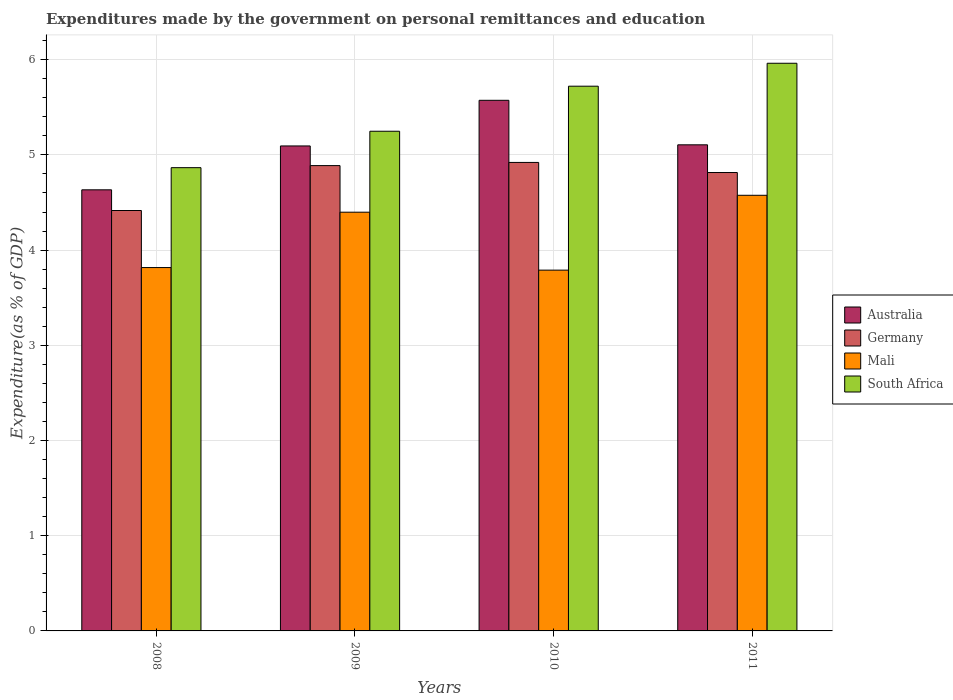How many different coloured bars are there?
Keep it short and to the point. 4. Are the number of bars per tick equal to the number of legend labels?
Keep it short and to the point. Yes. Are the number of bars on each tick of the X-axis equal?
Provide a succinct answer. Yes. In how many cases, is the number of bars for a given year not equal to the number of legend labels?
Keep it short and to the point. 0. What is the expenditures made by the government on personal remittances and education in Australia in 2011?
Your answer should be very brief. 5.11. Across all years, what is the maximum expenditures made by the government on personal remittances and education in South Africa?
Provide a short and direct response. 5.96. Across all years, what is the minimum expenditures made by the government on personal remittances and education in Germany?
Offer a terse response. 4.42. In which year was the expenditures made by the government on personal remittances and education in Mali minimum?
Make the answer very short. 2010. What is the total expenditures made by the government on personal remittances and education in Mali in the graph?
Offer a terse response. 16.58. What is the difference between the expenditures made by the government on personal remittances and education in Australia in 2008 and that in 2009?
Keep it short and to the point. -0.46. What is the difference between the expenditures made by the government on personal remittances and education in Australia in 2008 and the expenditures made by the government on personal remittances and education in Mali in 2009?
Make the answer very short. 0.24. What is the average expenditures made by the government on personal remittances and education in Germany per year?
Make the answer very short. 4.76. In the year 2008, what is the difference between the expenditures made by the government on personal remittances and education in South Africa and expenditures made by the government on personal remittances and education in Germany?
Offer a very short reply. 0.45. In how many years, is the expenditures made by the government on personal remittances and education in Germany greater than 2.2 %?
Ensure brevity in your answer.  4. What is the ratio of the expenditures made by the government on personal remittances and education in Germany in 2008 to that in 2010?
Make the answer very short. 0.9. What is the difference between the highest and the second highest expenditures made by the government on personal remittances and education in South Africa?
Give a very brief answer. 0.24. What is the difference between the highest and the lowest expenditures made by the government on personal remittances and education in Mali?
Ensure brevity in your answer.  0.79. Is it the case that in every year, the sum of the expenditures made by the government on personal remittances and education in Germany and expenditures made by the government on personal remittances and education in Australia is greater than the sum of expenditures made by the government on personal remittances and education in Mali and expenditures made by the government on personal remittances and education in South Africa?
Make the answer very short. No. What does the 1st bar from the left in 2008 represents?
Offer a terse response. Australia. What does the 2nd bar from the right in 2008 represents?
Ensure brevity in your answer.  Mali. Is it the case that in every year, the sum of the expenditures made by the government on personal remittances and education in Australia and expenditures made by the government on personal remittances and education in South Africa is greater than the expenditures made by the government on personal remittances and education in Mali?
Provide a succinct answer. Yes. Are all the bars in the graph horizontal?
Ensure brevity in your answer.  No. How many years are there in the graph?
Your response must be concise. 4. Does the graph contain grids?
Keep it short and to the point. Yes. Where does the legend appear in the graph?
Offer a terse response. Center right. How are the legend labels stacked?
Keep it short and to the point. Vertical. What is the title of the graph?
Offer a very short reply. Expenditures made by the government on personal remittances and education. Does "Europe(all income levels)" appear as one of the legend labels in the graph?
Ensure brevity in your answer.  No. What is the label or title of the X-axis?
Keep it short and to the point. Years. What is the label or title of the Y-axis?
Your answer should be very brief. Expenditure(as % of GDP). What is the Expenditure(as % of GDP) of Australia in 2008?
Make the answer very short. 4.63. What is the Expenditure(as % of GDP) of Germany in 2008?
Provide a short and direct response. 4.42. What is the Expenditure(as % of GDP) in Mali in 2008?
Make the answer very short. 3.82. What is the Expenditure(as % of GDP) in South Africa in 2008?
Give a very brief answer. 4.87. What is the Expenditure(as % of GDP) of Australia in 2009?
Offer a terse response. 5.09. What is the Expenditure(as % of GDP) of Germany in 2009?
Provide a short and direct response. 4.89. What is the Expenditure(as % of GDP) in Mali in 2009?
Offer a very short reply. 4.4. What is the Expenditure(as % of GDP) of South Africa in 2009?
Offer a terse response. 5.25. What is the Expenditure(as % of GDP) in Australia in 2010?
Offer a very short reply. 5.57. What is the Expenditure(as % of GDP) of Germany in 2010?
Make the answer very short. 4.92. What is the Expenditure(as % of GDP) of Mali in 2010?
Your answer should be compact. 3.79. What is the Expenditure(as % of GDP) in South Africa in 2010?
Offer a terse response. 5.72. What is the Expenditure(as % of GDP) of Australia in 2011?
Give a very brief answer. 5.11. What is the Expenditure(as % of GDP) of Germany in 2011?
Give a very brief answer. 4.81. What is the Expenditure(as % of GDP) of Mali in 2011?
Your answer should be very brief. 4.58. What is the Expenditure(as % of GDP) in South Africa in 2011?
Make the answer very short. 5.96. Across all years, what is the maximum Expenditure(as % of GDP) of Australia?
Give a very brief answer. 5.57. Across all years, what is the maximum Expenditure(as % of GDP) in Germany?
Offer a very short reply. 4.92. Across all years, what is the maximum Expenditure(as % of GDP) in Mali?
Provide a succinct answer. 4.58. Across all years, what is the maximum Expenditure(as % of GDP) of South Africa?
Give a very brief answer. 5.96. Across all years, what is the minimum Expenditure(as % of GDP) of Australia?
Make the answer very short. 4.63. Across all years, what is the minimum Expenditure(as % of GDP) in Germany?
Offer a very short reply. 4.42. Across all years, what is the minimum Expenditure(as % of GDP) of Mali?
Your response must be concise. 3.79. Across all years, what is the minimum Expenditure(as % of GDP) of South Africa?
Your answer should be compact. 4.87. What is the total Expenditure(as % of GDP) of Australia in the graph?
Ensure brevity in your answer.  20.41. What is the total Expenditure(as % of GDP) in Germany in the graph?
Offer a very short reply. 19.04. What is the total Expenditure(as % of GDP) of Mali in the graph?
Keep it short and to the point. 16.58. What is the total Expenditure(as % of GDP) in South Africa in the graph?
Your answer should be very brief. 21.8. What is the difference between the Expenditure(as % of GDP) of Australia in 2008 and that in 2009?
Give a very brief answer. -0.46. What is the difference between the Expenditure(as % of GDP) in Germany in 2008 and that in 2009?
Ensure brevity in your answer.  -0.47. What is the difference between the Expenditure(as % of GDP) in Mali in 2008 and that in 2009?
Your answer should be very brief. -0.58. What is the difference between the Expenditure(as % of GDP) in South Africa in 2008 and that in 2009?
Make the answer very short. -0.38. What is the difference between the Expenditure(as % of GDP) of Australia in 2008 and that in 2010?
Provide a succinct answer. -0.94. What is the difference between the Expenditure(as % of GDP) of Germany in 2008 and that in 2010?
Provide a short and direct response. -0.51. What is the difference between the Expenditure(as % of GDP) of Mali in 2008 and that in 2010?
Your answer should be very brief. 0.03. What is the difference between the Expenditure(as % of GDP) in South Africa in 2008 and that in 2010?
Give a very brief answer. -0.86. What is the difference between the Expenditure(as % of GDP) of Australia in 2008 and that in 2011?
Make the answer very short. -0.47. What is the difference between the Expenditure(as % of GDP) of Germany in 2008 and that in 2011?
Your answer should be very brief. -0.4. What is the difference between the Expenditure(as % of GDP) of Mali in 2008 and that in 2011?
Your answer should be very brief. -0.76. What is the difference between the Expenditure(as % of GDP) in South Africa in 2008 and that in 2011?
Provide a succinct answer. -1.1. What is the difference between the Expenditure(as % of GDP) in Australia in 2009 and that in 2010?
Make the answer very short. -0.48. What is the difference between the Expenditure(as % of GDP) in Germany in 2009 and that in 2010?
Keep it short and to the point. -0.03. What is the difference between the Expenditure(as % of GDP) in Mali in 2009 and that in 2010?
Your answer should be very brief. 0.61. What is the difference between the Expenditure(as % of GDP) of South Africa in 2009 and that in 2010?
Your answer should be very brief. -0.47. What is the difference between the Expenditure(as % of GDP) in Australia in 2009 and that in 2011?
Provide a short and direct response. -0.01. What is the difference between the Expenditure(as % of GDP) in Germany in 2009 and that in 2011?
Keep it short and to the point. 0.07. What is the difference between the Expenditure(as % of GDP) in Mali in 2009 and that in 2011?
Keep it short and to the point. -0.18. What is the difference between the Expenditure(as % of GDP) of South Africa in 2009 and that in 2011?
Offer a terse response. -0.71. What is the difference between the Expenditure(as % of GDP) of Australia in 2010 and that in 2011?
Ensure brevity in your answer.  0.47. What is the difference between the Expenditure(as % of GDP) of Germany in 2010 and that in 2011?
Provide a short and direct response. 0.11. What is the difference between the Expenditure(as % of GDP) in Mali in 2010 and that in 2011?
Your response must be concise. -0.79. What is the difference between the Expenditure(as % of GDP) in South Africa in 2010 and that in 2011?
Your response must be concise. -0.24. What is the difference between the Expenditure(as % of GDP) of Australia in 2008 and the Expenditure(as % of GDP) of Germany in 2009?
Make the answer very short. -0.25. What is the difference between the Expenditure(as % of GDP) in Australia in 2008 and the Expenditure(as % of GDP) in Mali in 2009?
Your answer should be compact. 0.23. What is the difference between the Expenditure(as % of GDP) in Australia in 2008 and the Expenditure(as % of GDP) in South Africa in 2009?
Keep it short and to the point. -0.62. What is the difference between the Expenditure(as % of GDP) of Germany in 2008 and the Expenditure(as % of GDP) of Mali in 2009?
Offer a very short reply. 0.02. What is the difference between the Expenditure(as % of GDP) in Germany in 2008 and the Expenditure(as % of GDP) in South Africa in 2009?
Provide a short and direct response. -0.83. What is the difference between the Expenditure(as % of GDP) in Mali in 2008 and the Expenditure(as % of GDP) in South Africa in 2009?
Your answer should be very brief. -1.43. What is the difference between the Expenditure(as % of GDP) in Australia in 2008 and the Expenditure(as % of GDP) in Germany in 2010?
Your answer should be compact. -0.29. What is the difference between the Expenditure(as % of GDP) in Australia in 2008 and the Expenditure(as % of GDP) in Mali in 2010?
Keep it short and to the point. 0.84. What is the difference between the Expenditure(as % of GDP) in Australia in 2008 and the Expenditure(as % of GDP) in South Africa in 2010?
Ensure brevity in your answer.  -1.09. What is the difference between the Expenditure(as % of GDP) in Germany in 2008 and the Expenditure(as % of GDP) in Mali in 2010?
Offer a terse response. 0.63. What is the difference between the Expenditure(as % of GDP) of Germany in 2008 and the Expenditure(as % of GDP) of South Africa in 2010?
Offer a very short reply. -1.31. What is the difference between the Expenditure(as % of GDP) of Mali in 2008 and the Expenditure(as % of GDP) of South Africa in 2010?
Ensure brevity in your answer.  -1.9. What is the difference between the Expenditure(as % of GDP) in Australia in 2008 and the Expenditure(as % of GDP) in Germany in 2011?
Provide a short and direct response. -0.18. What is the difference between the Expenditure(as % of GDP) in Australia in 2008 and the Expenditure(as % of GDP) in Mali in 2011?
Provide a short and direct response. 0.06. What is the difference between the Expenditure(as % of GDP) of Australia in 2008 and the Expenditure(as % of GDP) of South Africa in 2011?
Your response must be concise. -1.33. What is the difference between the Expenditure(as % of GDP) of Germany in 2008 and the Expenditure(as % of GDP) of Mali in 2011?
Provide a succinct answer. -0.16. What is the difference between the Expenditure(as % of GDP) in Germany in 2008 and the Expenditure(as % of GDP) in South Africa in 2011?
Your answer should be very brief. -1.55. What is the difference between the Expenditure(as % of GDP) of Mali in 2008 and the Expenditure(as % of GDP) of South Africa in 2011?
Keep it short and to the point. -2.15. What is the difference between the Expenditure(as % of GDP) of Australia in 2009 and the Expenditure(as % of GDP) of Germany in 2010?
Offer a very short reply. 0.17. What is the difference between the Expenditure(as % of GDP) in Australia in 2009 and the Expenditure(as % of GDP) in Mali in 2010?
Offer a terse response. 1.3. What is the difference between the Expenditure(as % of GDP) in Australia in 2009 and the Expenditure(as % of GDP) in South Africa in 2010?
Ensure brevity in your answer.  -0.63. What is the difference between the Expenditure(as % of GDP) in Germany in 2009 and the Expenditure(as % of GDP) in Mali in 2010?
Make the answer very short. 1.1. What is the difference between the Expenditure(as % of GDP) in Germany in 2009 and the Expenditure(as % of GDP) in South Africa in 2010?
Your answer should be very brief. -0.83. What is the difference between the Expenditure(as % of GDP) in Mali in 2009 and the Expenditure(as % of GDP) in South Africa in 2010?
Offer a terse response. -1.32. What is the difference between the Expenditure(as % of GDP) of Australia in 2009 and the Expenditure(as % of GDP) of Germany in 2011?
Give a very brief answer. 0.28. What is the difference between the Expenditure(as % of GDP) of Australia in 2009 and the Expenditure(as % of GDP) of Mali in 2011?
Offer a very short reply. 0.52. What is the difference between the Expenditure(as % of GDP) in Australia in 2009 and the Expenditure(as % of GDP) in South Africa in 2011?
Make the answer very short. -0.87. What is the difference between the Expenditure(as % of GDP) in Germany in 2009 and the Expenditure(as % of GDP) in Mali in 2011?
Your answer should be compact. 0.31. What is the difference between the Expenditure(as % of GDP) in Germany in 2009 and the Expenditure(as % of GDP) in South Africa in 2011?
Provide a short and direct response. -1.08. What is the difference between the Expenditure(as % of GDP) of Mali in 2009 and the Expenditure(as % of GDP) of South Africa in 2011?
Make the answer very short. -1.56. What is the difference between the Expenditure(as % of GDP) in Australia in 2010 and the Expenditure(as % of GDP) in Germany in 2011?
Provide a short and direct response. 0.76. What is the difference between the Expenditure(as % of GDP) in Australia in 2010 and the Expenditure(as % of GDP) in Mali in 2011?
Your answer should be compact. 1. What is the difference between the Expenditure(as % of GDP) in Australia in 2010 and the Expenditure(as % of GDP) in South Africa in 2011?
Offer a terse response. -0.39. What is the difference between the Expenditure(as % of GDP) of Germany in 2010 and the Expenditure(as % of GDP) of Mali in 2011?
Ensure brevity in your answer.  0.34. What is the difference between the Expenditure(as % of GDP) in Germany in 2010 and the Expenditure(as % of GDP) in South Africa in 2011?
Provide a succinct answer. -1.04. What is the difference between the Expenditure(as % of GDP) in Mali in 2010 and the Expenditure(as % of GDP) in South Africa in 2011?
Keep it short and to the point. -2.17. What is the average Expenditure(as % of GDP) of Australia per year?
Your answer should be compact. 5.1. What is the average Expenditure(as % of GDP) in Germany per year?
Keep it short and to the point. 4.76. What is the average Expenditure(as % of GDP) of Mali per year?
Make the answer very short. 4.15. What is the average Expenditure(as % of GDP) in South Africa per year?
Give a very brief answer. 5.45. In the year 2008, what is the difference between the Expenditure(as % of GDP) of Australia and Expenditure(as % of GDP) of Germany?
Offer a very short reply. 0.22. In the year 2008, what is the difference between the Expenditure(as % of GDP) of Australia and Expenditure(as % of GDP) of Mali?
Your answer should be compact. 0.82. In the year 2008, what is the difference between the Expenditure(as % of GDP) of Australia and Expenditure(as % of GDP) of South Africa?
Your answer should be compact. -0.23. In the year 2008, what is the difference between the Expenditure(as % of GDP) in Germany and Expenditure(as % of GDP) in Mali?
Make the answer very short. 0.6. In the year 2008, what is the difference between the Expenditure(as % of GDP) of Germany and Expenditure(as % of GDP) of South Africa?
Keep it short and to the point. -0.45. In the year 2008, what is the difference between the Expenditure(as % of GDP) of Mali and Expenditure(as % of GDP) of South Africa?
Provide a short and direct response. -1.05. In the year 2009, what is the difference between the Expenditure(as % of GDP) of Australia and Expenditure(as % of GDP) of Germany?
Your answer should be compact. 0.21. In the year 2009, what is the difference between the Expenditure(as % of GDP) in Australia and Expenditure(as % of GDP) in Mali?
Make the answer very short. 0.7. In the year 2009, what is the difference between the Expenditure(as % of GDP) of Australia and Expenditure(as % of GDP) of South Africa?
Offer a terse response. -0.15. In the year 2009, what is the difference between the Expenditure(as % of GDP) of Germany and Expenditure(as % of GDP) of Mali?
Offer a very short reply. 0.49. In the year 2009, what is the difference between the Expenditure(as % of GDP) of Germany and Expenditure(as % of GDP) of South Africa?
Your response must be concise. -0.36. In the year 2009, what is the difference between the Expenditure(as % of GDP) in Mali and Expenditure(as % of GDP) in South Africa?
Offer a very short reply. -0.85. In the year 2010, what is the difference between the Expenditure(as % of GDP) of Australia and Expenditure(as % of GDP) of Germany?
Your response must be concise. 0.65. In the year 2010, what is the difference between the Expenditure(as % of GDP) in Australia and Expenditure(as % of GDP) in Mali?
Your answer should be very brief. 1.78. In the year 2010, what is the difference between the Expenditure(as % of GDP) in Australia and Expenditure(as % of GDP) in South Africa?
Give a very brief answer. -0.15. In the year 2010, what is the difference between the Expenditure(as % of GDP) of Germany and Expenditure(as % of GDP) of Mali?
Provide a short and direct response. 1.13. In the year 2010, what is the difference between the Expenditure(as % of GDP) of Germany and Expenditure(as % of GDP) of South Africa?
Keep it short and to the point. -0.8. In the year 2010, what is the difference between the Expenditure(as % of GDP) of Mali and Expenditure(as % of GDP) of South Africa?
Keep it short and to the point. -1.93. In the year 2011, what is the difference between the Expenditure(as % of GDP) of Australia and Expenditure(as % of GDP) of Germany?
Give a very brief answer. 0.29. In the year 2011, what is the difference between the Expenditure(as % of GDP) in Australia and Expenditure(as % of GDP) in Mali?
Provide a succinct answer. 0.53. In the year 2011, what is the difference between the Expenditure(as % of GDP) of Australia and Expenditure(as % of GDP) of South Africa?
Ensure brevity in your answer.  -0.86. In the year 2011, what is the difference between the Expenditure(as % of GDP) in Germany and Expenditure(as % of GDP) in Mali?
Make the answer very short. 0.24. In the year 2011, what is the difference between the Expenditure(as % of GDP) in Germany and Expenditure(as % of GDP) in South Africa?
Your answer should be very brief. -1.15. In the year 2011, what is the difference between the Expenditure(as % of GDP) in Mali and Expenditure(as % of GDP) in South Africa?
Your answer should be very brief. -1.39. What is the ratio of the Expenditure(as % of GDP) in Australia in 2008 to that in 2009?
Offer a very short reply. 0.91. What is the ratio of the Expenditure(as % of GDP) of Germany in 2008 to that in 2009?
Ensure brevity in your answer.  0.9. What is the ratio of the Expenditure(as % of GDP) in Mali in 2008 to that in 2009?
Your answer should be very brief. 0.87. What is the ratio of the Expenditure(as % of GDP) of South Africa in 2008 to that in 2009?
Your answer should be compact. 0.93. What is the ratio of the Expenditure(as % of GDP) of Australia in 2008 to that in 2010?
Offer a very short reply. 0.83. What is the ratio of the Expenditure(as % of GDP) of Germany in 2008 to that in 2010?
Your response must be concise. 0.9. What is the ratio of the Expenditure(as % of GDP) of Mali in 2008 to that in 2010?
Provide a succinct answer. 1.01. What is the ratio of the Expenditure(as % of GDP) of South Africa in 2008 to that in 2010?
Make the answer very short. 0.85. What is the ratio of the Expenditure(as % of GDP) in Australia in 2008 to that in 2011?
Your answer should be very brief. 0.91. What is the ratio of the Expenditure(as % of GDP) of Germany in 2008 to that in 2011?
Provide a succinct answer. 0.92. What is the ratio of the Expenditure(as % of GDP) in Mali in 2008 to that in 2011?
Make the answer very short. 0.83. What is the ratio of the Expenditure(as % of GDP) of South Africa in 2008 to that in 2011?
Your answer should be compact. 0.82. What is the ratio of the Expenditure(as % of GDP) of Australia in 2009 to that in 2010?
Give a very brief answer. 0.91. What is the ratio of the Expenditure(as % of GDP) of Mali in 2009 to that in 2010?
Make the answer very short. 1.16. What is the ratio of the Expenditure(as % of GDP) of South Africa in 2009 to that in 2010?
Offer a terse response. 0.92. What is the ratio of the Expenditure(as % of GDP) in Australia in 2009 to that in 2011?
Give a very brief answer. 1. What is the ratio of the Expenditure(as % of GDP) of Germany in 2009 to that in 2011?
Keep it short and to the point. 1.02. What is the ratio of the Expenditure(as % of GDP) in Mali in 2009 to that in 2011?
Offer a very short reply. 0.96. What is the ratio of the Expenditure(as % of GDP) in South Africa in 2009 to that in 2011?
Your answer should be compact. 0.88. What is the ratio of the Expenditure(as % of GDP) of Australia in 2010 to that in 2011?
Give a very brief answer. 1.09. What is the ratio of the Expenditure(as % of GDP) of Germany in 2010 to that in 2011?
Offer a terse response. 1.02. What is the ratio of the Expenditure(as % of GDP) of Mali in 2010 to that in 2011?
Your answer should be compact. 0.83. What is the ratio of the Expenditure(as % of GDP) of South Africa in 2010 to that in 2011?
Make the answer very short. 0.96. What is the difference between the highest and the second highest Expenditure(as % of GDP) in Australia?
Provide a short and direct response. 0.47. What is the difference between the highest and the second highest Expenditure(as % of GDP) in Mali?
Offer a terse response. 0.18. What is the difference between the highest and the second highest Expenditure(as % of GDP) of South Africa?
Keep it short and to the point. 0.24. What is the difference between the highest and the lowest Expenditure(as % of GDP) of Australia?
Your answer should be very brief. 0.94. What is the difference between the highest and the lowest Expenditure(as % of GDP) of Germany?
Give a very brief answer. 0.51. What is the difference between the highest and the lowest Expenditure(as % of GDP) in Mali?
Your answer should be very brief. 0.79. What is the difference between the highest and the lowest Expenditure(as % of GDP) in South Africa?
Your answer should be compact. 1.1. 